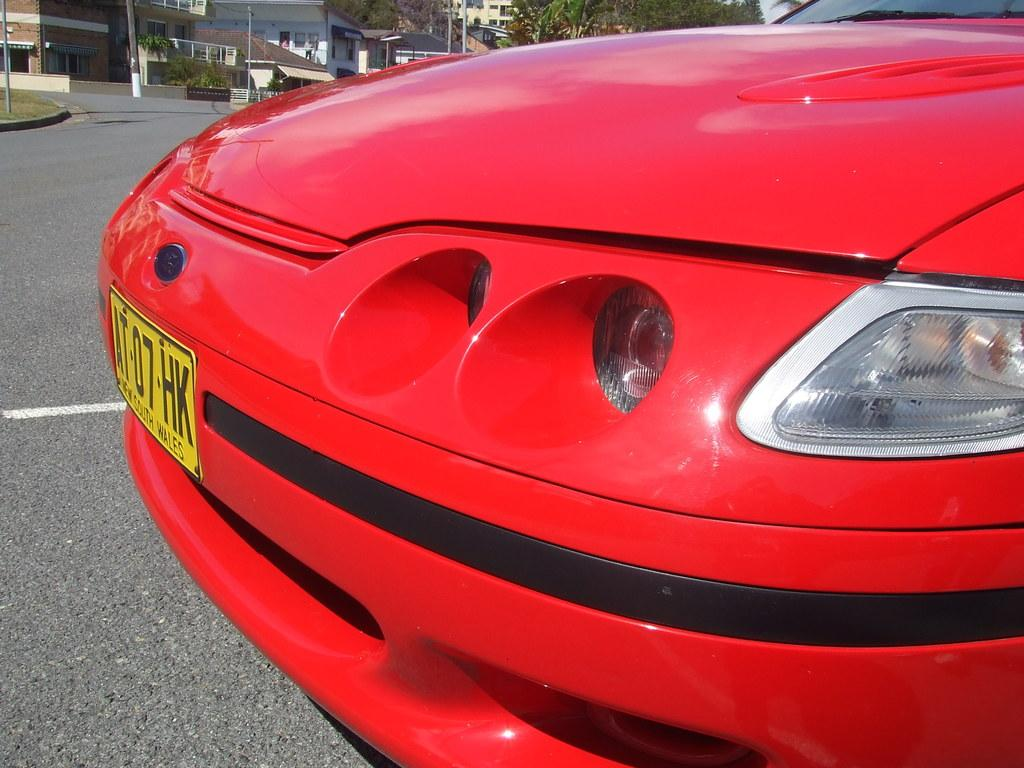What is the main subject of the image? The main subject of the image is a car. Can you describe the color of the car? The car is red and black in color. Where is the car located in the image? The car is on the road. What can be seen in the background of the image? There are buildings, poles, and trees in the background of the image. What type of sponge is being used to clean the car in the image? There is no sponge visible in the image, and no cleaning activity is taking place. 